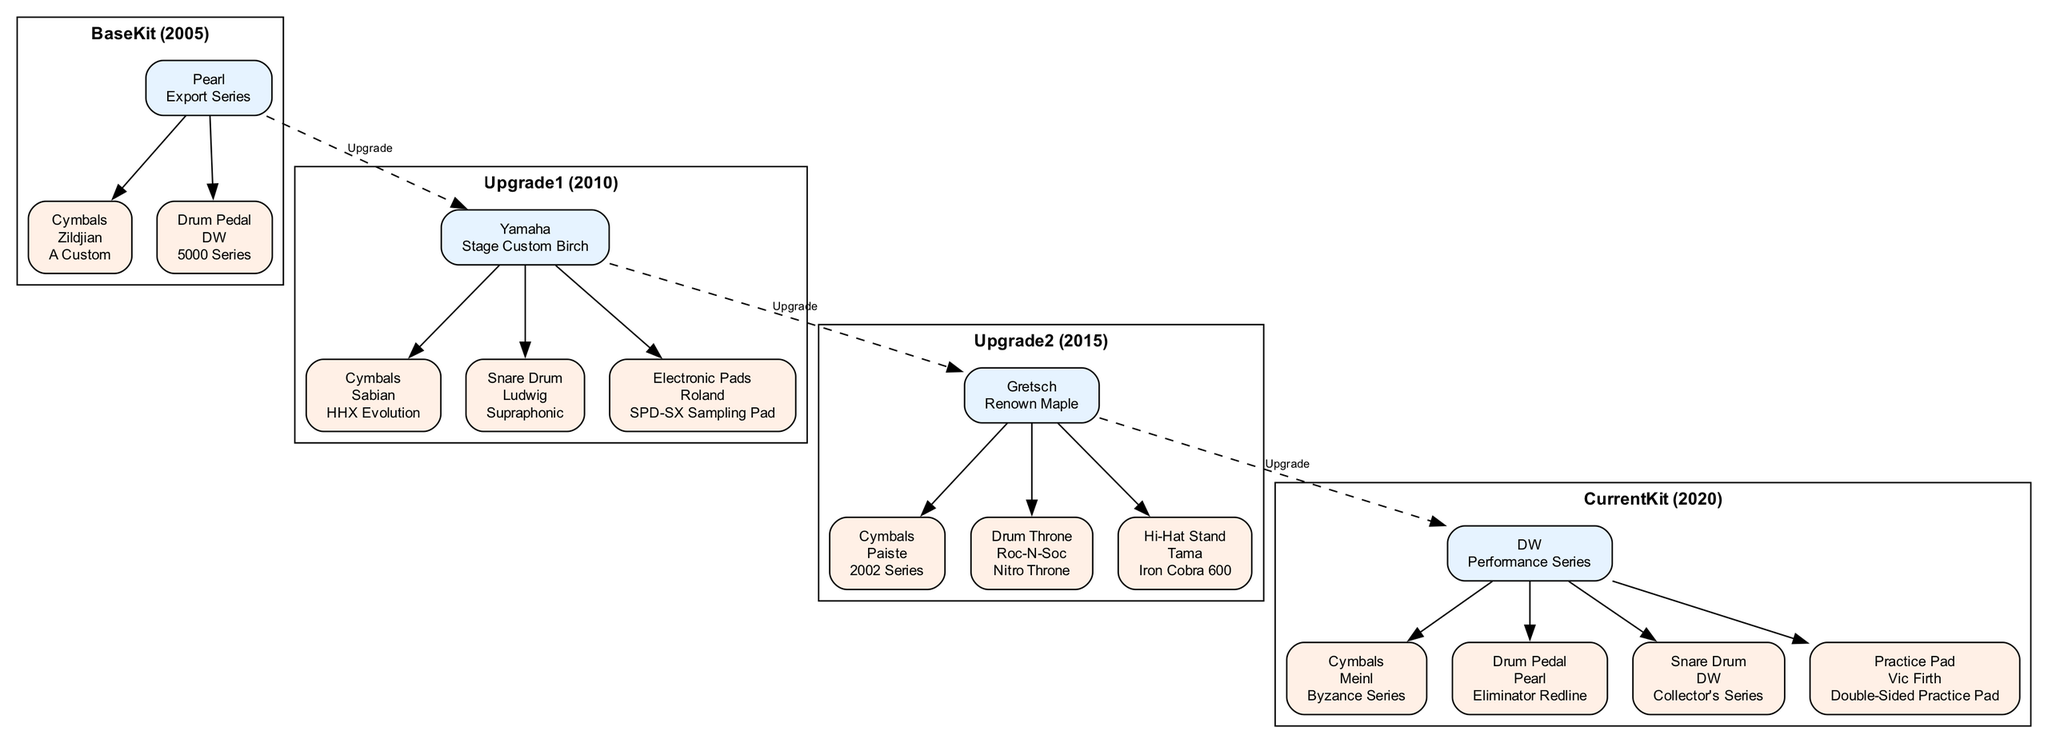What brand is the current kit? The current kit node in the diagram indicates the brand as "DW." The answer can be directly read from this node.
Answer: DW What year was the upgrade 1 kit acquired? The upgrade 1 kit node specifies the year acquired as "2010." This information is presented in the node label.
Answer: 2010 How many key accessories are listed for the upgrade 2 kit? The upgrade 2 kit node lists three key accessories, as indicated by the number of accessory nodes connected to it.
Answer: 3 Which model snare drum is associated with the current kit? The accessory node for the snare drum connected to the current kit specifies the model as "Collector's Series." This is found in the accessory details.
Answer: Collector's Series What is the relationship between the base kit and upgrade 1? The diagram shows a dashed edge labeled "Upgrade" connecting the base kit to upgrade 1, indicating that upgrade 1 is an improved version of the base kit.
Answer: Upgrade Which accessory brand was used with the upgrade 2 kit's drum throne? The upgrade 2 kit's drum throne accessory node specifies that the brand is "Roc-N-Soc." This information is visible in the accessory details.
Answer: Roc-N-Soc Which model of cymbals was used with the first kit? The base kit includes a key accessory of cymbals with the model "A Custom," which is detailed in the accessory list under the base kit node.
Answer: A Custom What was the last kit acquired before the current kit? The current kit follows the upgrade 2 kit chronologically, so the last kit acquired before it is the upgrade 2 kit, which is labeled as "Upgrade2" in the diagram.
Answer: Upgrade2 What type of accessory is associated with the upgrade 1 kit? The upgrade 1 kit has three types of accessories: cymbals, snare drum, and electronic pads, indicating a diverse set of enhancements. The types are read from the connected accessory nodes.
Answer: Cymbals, Snare Drum, Electronic Pads 